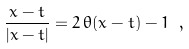<formula> <loc_0><loc_0><loc_500><loc_500>\frac { x - t } { | x - t | } = 2 \, \theta ( x - t ) - 1 \ ,</formula> 